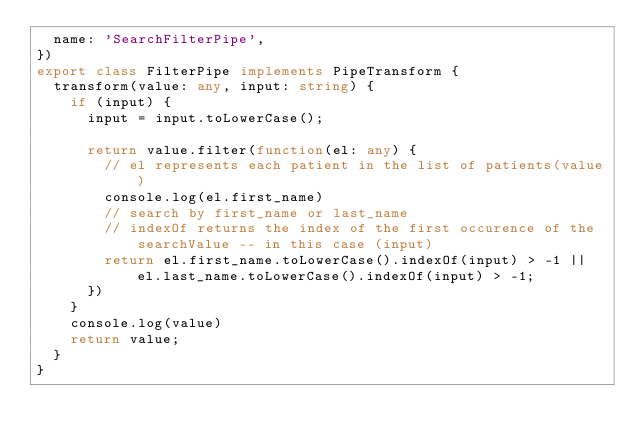<code> <loc_0><loc_0><loc_500><loc_500><_TypeScript_>  name: 'SearchFilterPipe',
})
export class FilterPipe implements PipeTransform {
  transform(value: any, input: string) {
    if (input) {
      input = input.toLowerCase();

      return value.filter(function(el: any) {
        // el represents each patient in the list of patients(value)
        console.log(el.first_name)
        // search by first_name or last_name
        // indexOf returns the index of the first occurence of the searchValue -- in this case (input)
        return el.first_name.toLowerCase().indexOf(input) > -1 || el.last_name.toLowerCase().indexOf(input) > -1;
      })
    }
    console.log(value)
    return value;
  }
}
</code> 